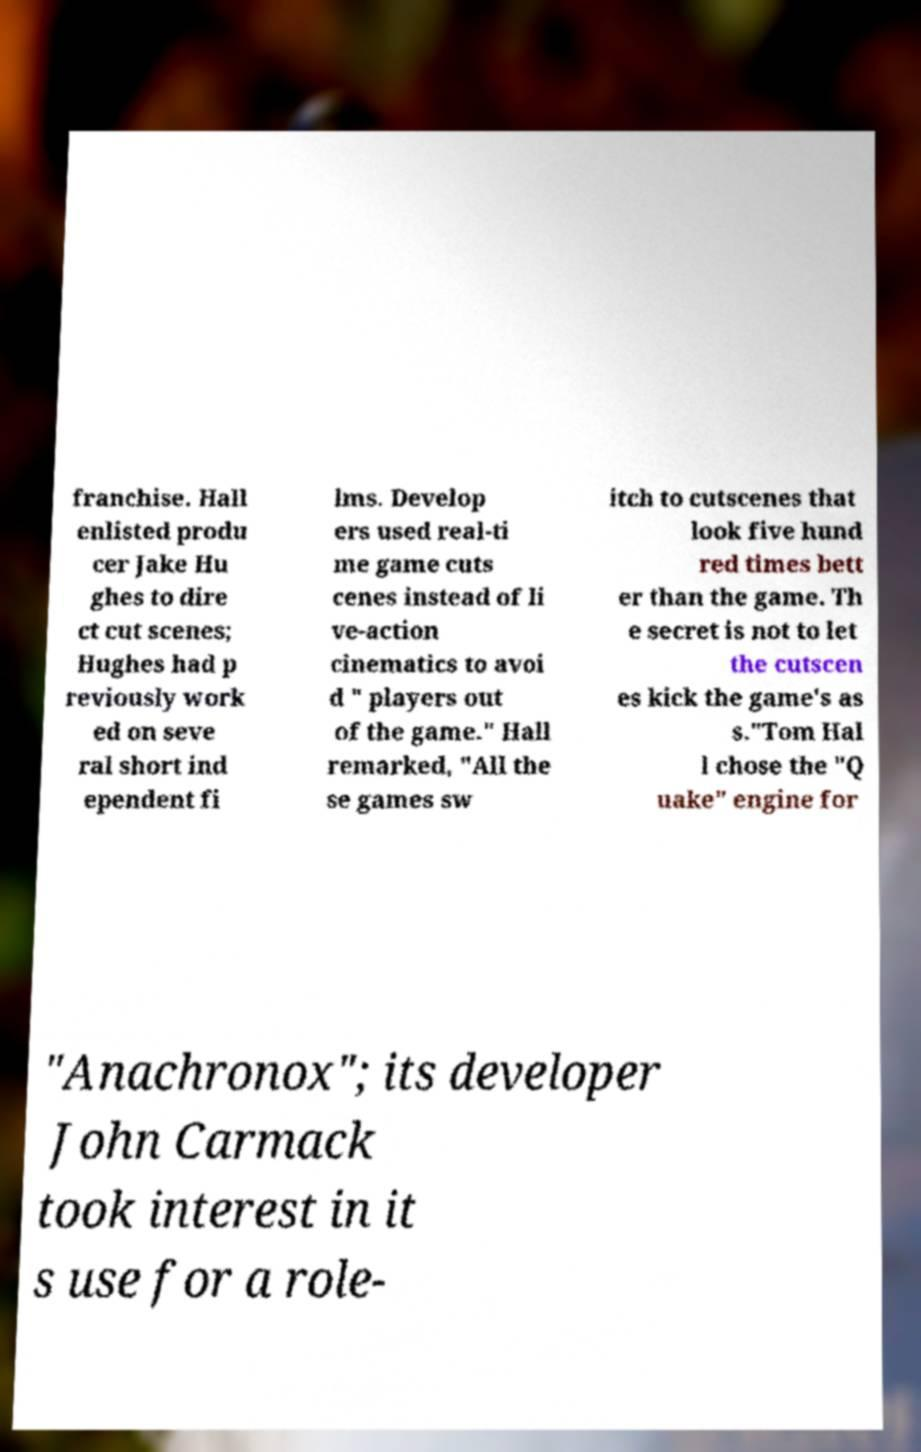For documentation purposes, I need the text within this image transcribed. Could you provide that? franchise. Hall enlisted produ cer Jake Hu ghes to dire ct cut scenes; Hughes had p reviously work ed on seve ral short ind ependent fi lms. Develop ers used real-ti me game cuts cenes instead of li ve-action cinematics to avoi d " players out of the game." Hall remarked, "All the se games sw itch to cutscenes that look five hund red times bett er than the game. Th e secret is not to let the cutscen es kick the game's as s."Tom Hal l chose the "Q uake" engine for "Anachronox"; its developer John Carmack took interest in it s use for a role- 